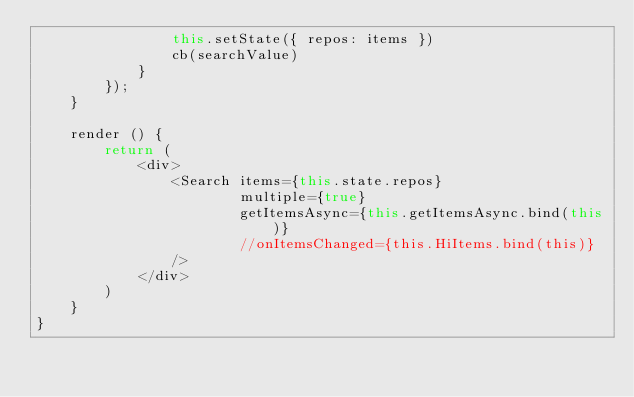Convert code to text. <code><loc_0><loc_0><loc_500><loc_500><_JavaScript_>                this.setState({ repos: items })
                cb(searchValue)
            }
        });
    }

    render () {
        return (
            <div>
                <Search items={this.state.repos}
                        multiple={true}
                        getItemsAsync={this.getItemsAsync.bind(this)}
                        //onItemsChanged={this.HiItems.bind(this)}
                />
            </div>
        )
    }
}</code> 